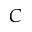Convert formula to latex. <formula><loc_0><loc_0><loc_500><loc_500>C</formula> 